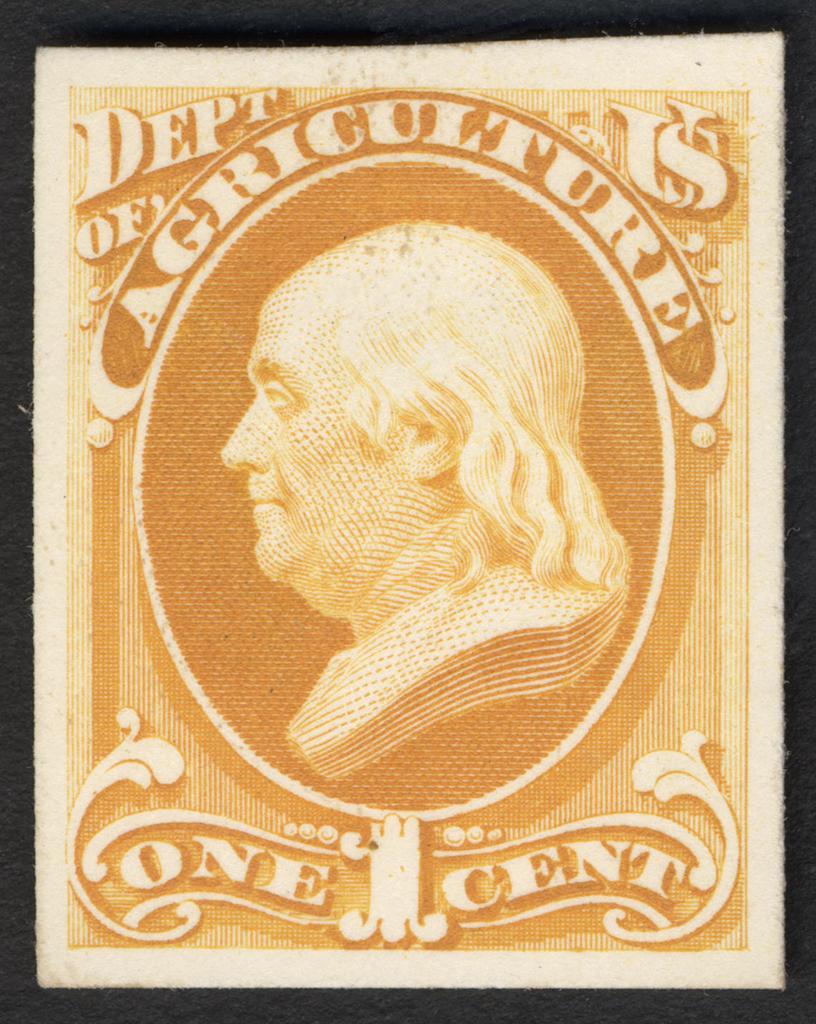Please provide a concise description of this image. In the image i can see the photo frame of the person and some text written on it. 